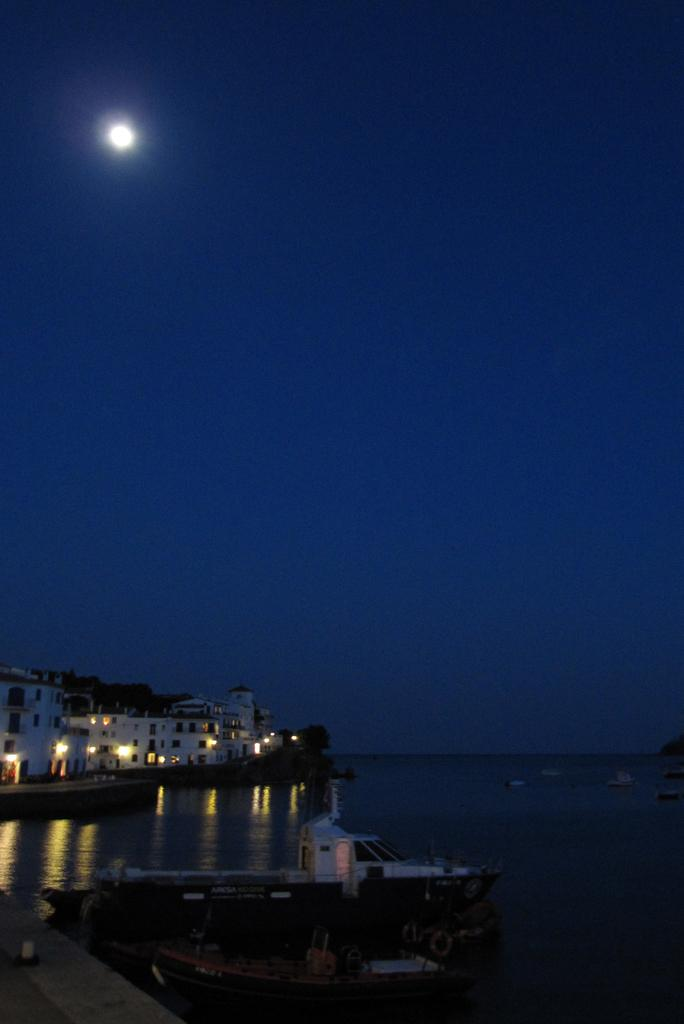What is the main subject of the image? The main subject of the image is a boat. Where is the boat located? The boat is on the water. What can be seen in the background of the image? There are buildings and lights visible in the background. What celestial body is present in the sky? The moon is present in the sky. How many support beams are visible in the image? There are no support beams present in the image; it features a boat on the water with buildings and lights in the background. Can you purchase a ticket for the boat ride in the image? There is no indication in the image that a boat ride is available or that tickets can be purchased. 